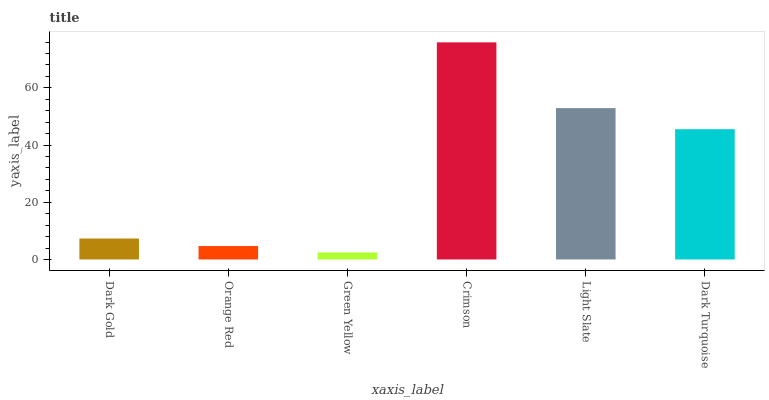Is Orange Red the minimum?
Answer yes or no. No. Is Orange Red the maximum?
Answer yes or no. No. Is Dark Gold greater than Orange Red?
Answer yes or no. Yes. Is Orange Red less than Dark Gold?
Answer yes or no. Yes. Is Orange Red greater than Dark Gold?
Answer yes or no. No. Is Dark Gold less than Orange Red?
Answer yes or no. No. Is Dark Turquoise the high median?
Answer yes or no. Yes. Is Dark Gold the low median?
Answer yes or no. Yes. Is Light Slate the high median?
Answer yes or no. No. Is Light Slate the low median?
Answer yes or no. No. 